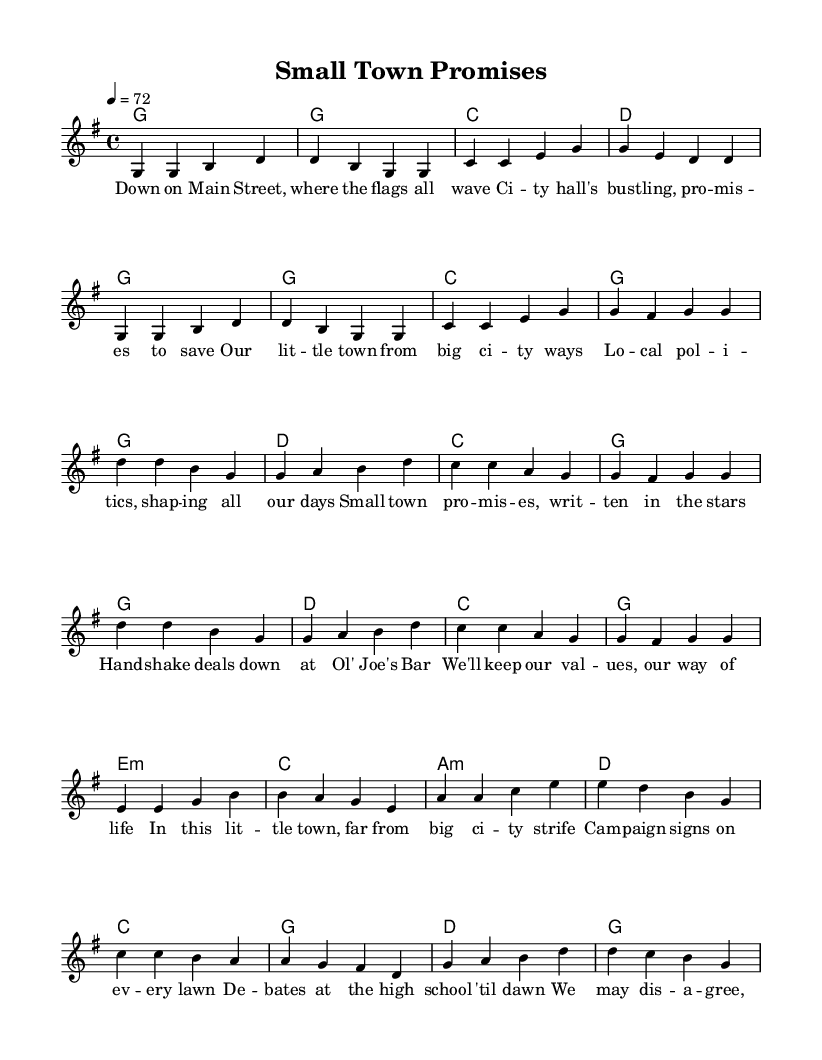What is the key signature of this music? The key signature is G major, which has one sharp (F#) indicated in the key signature section at the beginning of the score.
Answer: G major What is the time signature of this music? The time signature shown in the score is 4/4, meaning there are four beats in each measure and the quarter note gets one beat.
Answer: 4/4 What is the tempo marking of this piece? The tempo marking specified in the score is 4 = 72, indicating that the quarter note should be played at 72 beats per minute.
Answer: 72 How many measures are there in the chorus? By counting the measures in the chorus section, there are a total of 8 measures given in this part of the song where the lyrics are repeated.
Answer: 8 What musical form does this piece follow? The piece follows a typical country ballad structure comprising verses, a chorus, and a bridge, with a repeated chorus which indicates a classic form.
Answer: Verse-Chorus-Bridge What emotion or theme does the bridge convey? The bridge presents a theme of unity and camaraderie among small-town residents during local political activities, illustrating connection despite differences.
Answer: Unity What local setting or aspect is depicted in the lyrics? The lyrics depict life in a small town, referencing local government (city hall), community activities (debates), and cultural touchpoints (Ol' Joe's Bar), capturing small-town dynamics.
Answer: Small town 